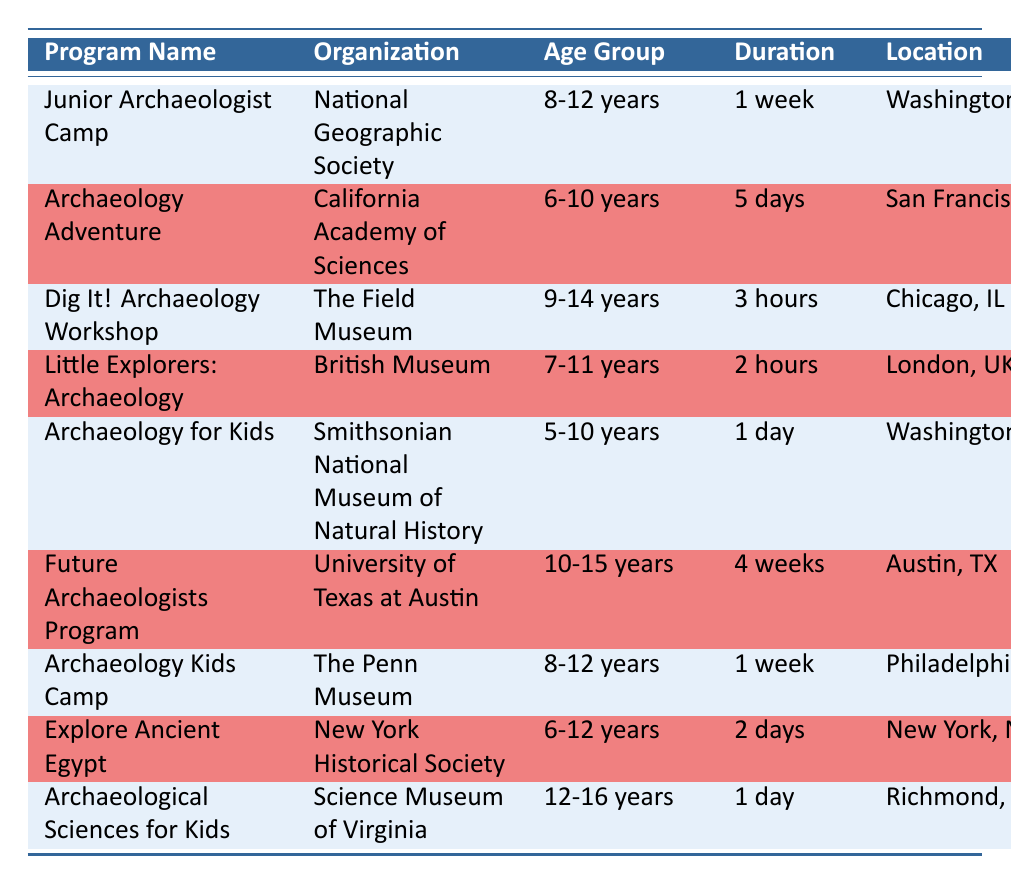What is the program name offered by the National Geographic Society? The table provides the details for programs, and the row for the National Geographic Society lists "Junior Archaeologist Camp" as the program name.
Answer: Junior Archaeologist Camp How long is the duration of the Future Archaeologists Program? Looking at the row for the Future Archaeologists Program in the table, it specifies that the duration is "4 weeks."
Answer: 4 weeks Which program has the longest duration for children aged 10-15 years? The only program listed specifically for ages 10-15 is the Future Archaeologists Program, which has a duration of "4 weeks," making it the longest program for that age group.
Answer: Future Archaeologists Program (4 weeks) Is there a program available for children under 6 years of age? The table lists age groups for each program, and the youngest age group mentioned is "5-10 years" for the Archaeology for Kids program. Since there are no programs for children under 5, the answer is no.
Answer: No Which workshop is located in London and what is its duration? Referring to the table, the program located in London is "Little Explorers: Archaeology," and it has a duration of "2 hours."
Answer: Little Explorers: Archaeology, 2 hours How many total programs listed are designed specifically for ages 9 years and older? From the table, the age groups identified as 9 years and older include "Dig It! Archaeology Workshop," "Future Archaeologists Program," "Archaeology Kids Camp," and "Archaeological Sciences for Kids." Counting them gives a total of 4 programs.
Answer: 4 What is the common age group for the Junior Archaeologist Camp and the Archaeology Kids Camp? Both programs list "8-12 years" as their age group. The table shows this information distinctly for each program.
Answer: 8-12 years Are there any programs with a duration of one day? The table indicates that the "Archaeology for Kids" and "Archaeological Sciences for Kids" programs both have a duration of "1 day." Thus, the answer is yes.
Answer: Yes What is the average duration of the programs for ages 6-10 years? There are two programs for this age group: "Archaeology Adventure" (5 days) and "Archaeology for Kids" (1 day). Converting 5 days to a common scale (1 week = 7 days), we can average them as (5+1)/2 = 3 days.
Answer: 3 days 